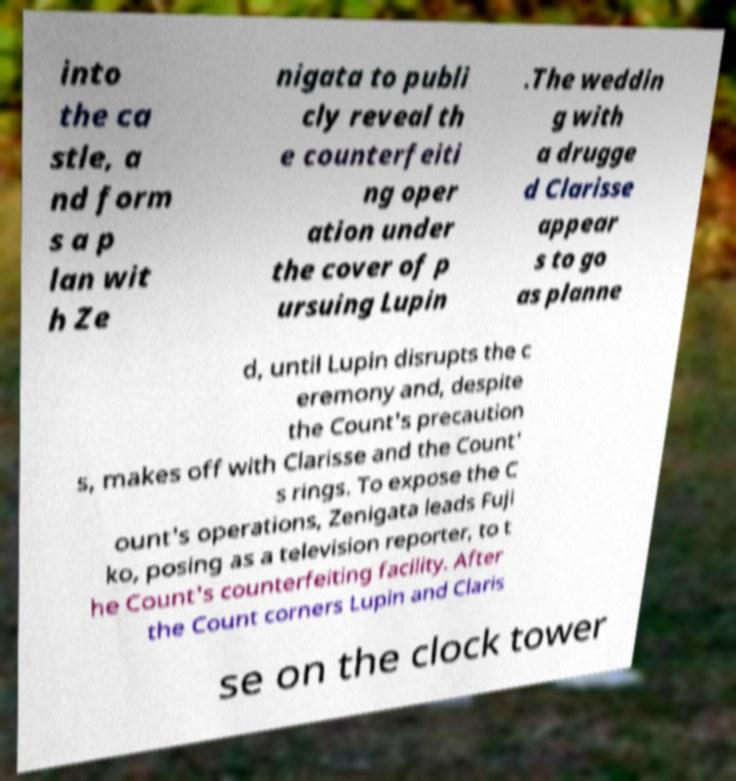There's text embedded in this image that I need extracted. Can you transcribe it verbatim? into the ca stle, a nd form s a p lan wit h Ze nigata to publi cly reveal th e counterfeiti ng oper ation under the cover of p ursuing Lupin .The weddin g with a drugge d Clarisse appear s to go as planne d, until Lupin disrupts the c eremony and, despite the Count's precaution s, makes off with Clarisse and the Count' s rings. To expose the C ount's operations, Zenigata leads Fuji ko, posing as a television reporter, to t he Count's counterfeiting facility. After the Count corners Lupin and Claris se on the clock tower 